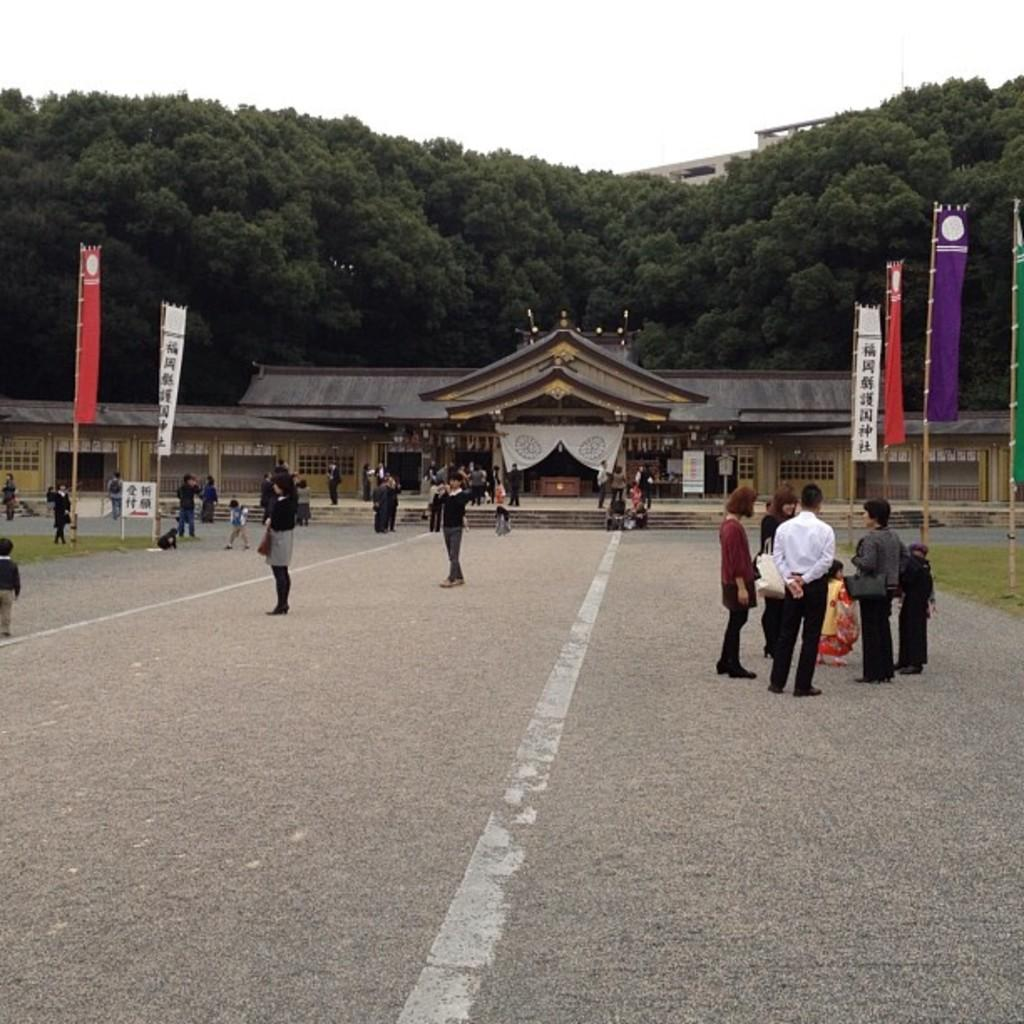How many people are in the group that is visible in the image? There is a group of people standing in the image, but the exact number cannot be determined from the provided facts. What can be seen in the background of the image? In the background of the image, there are banners, a building, trees, and the sky. Can you describe the banners in the image? The banners in the image have multiple colors. What is the color of the building in the background? The building in the background of the image is brown. What is the color of the trees in the background? The trees in the background of the image are green. What is the color of the sky in the background? The sky in the background of the image is white. What type of clover is being used as a chess piece in the image? There is no clover or chess pieces present in the image. How many flights are visible in the image? There are no flights visible in the image. 